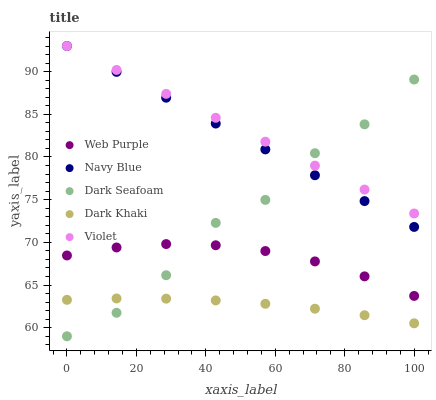Does Dark Khaki have the minimum area under the curve?
Answer yes or no. Yes. Does Violet have the maximum area under the curve?
Answer yes or no. Yes. Does Navy Blue have the minimum area under the curve?
Answer yes or no. No. Does Navy Blue have the maximum area under the curve?
Answer yes or no. No. Is Violet the smoothest?
Answer yes or no. Yes. Is Dark Seafoam the roughest?
Answer yes or no. Yes. Is Navy Blue the smoothest?
Answer yes or no. No. Is Navy Blue the roughest?
Answer yes or no. No. Does Dark Seafoam have the lowest value?
Answer yes or no. Yes. Does Navy Blue have the lowest value?
Answer yes or no. No. Does Violet have the highest value?
Answer yes or no. Yes. Does Web Purple have the highest value?
Answer yes or no. No. Is Web Purple less than Violet?
Answer yes or no. Yes. Is Violet greater than Dark Khaki?
Answer yes or no. Yes. Does Dark Seafoam intersect Web Purple?
Answer yes or no. Yes. Is Dark Seafoam less than Web Purple?
Answer yes or no. No. Is Dark Seafoam greater than Web Purple?
Answer yes or no. No. Does Web Purple intersect Violet?
Answer yes or no. No. 